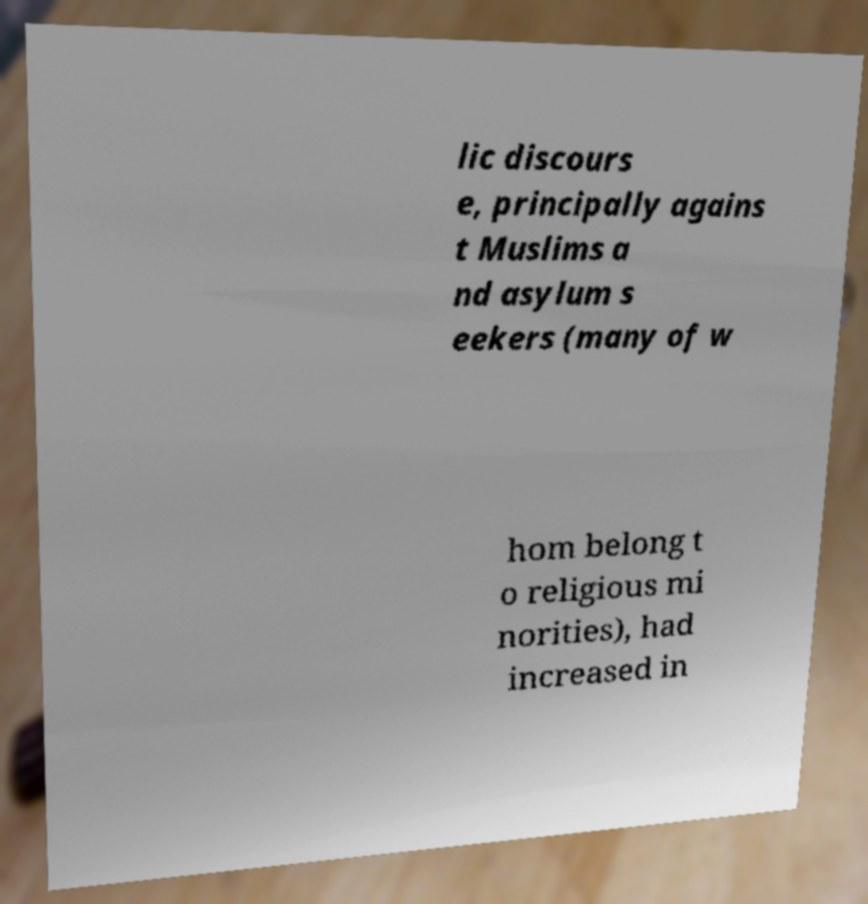Can you accurately transcribe the text from the provided image for me? lic discours e, principally agains t Muslims a nd asylum s eekers (many of w hom belong t o religious mi norities), had increased in 